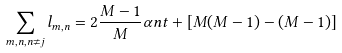<formula> <loc_0><loc_0><loc_500><loc_500>\sum _ { m , n , n \neq j } l _ { m , n } = 2 \frac { M - 1 } { M } \alpha n t + [ M ( M - 1 ) - ( M - 1 ) ]</formula> 